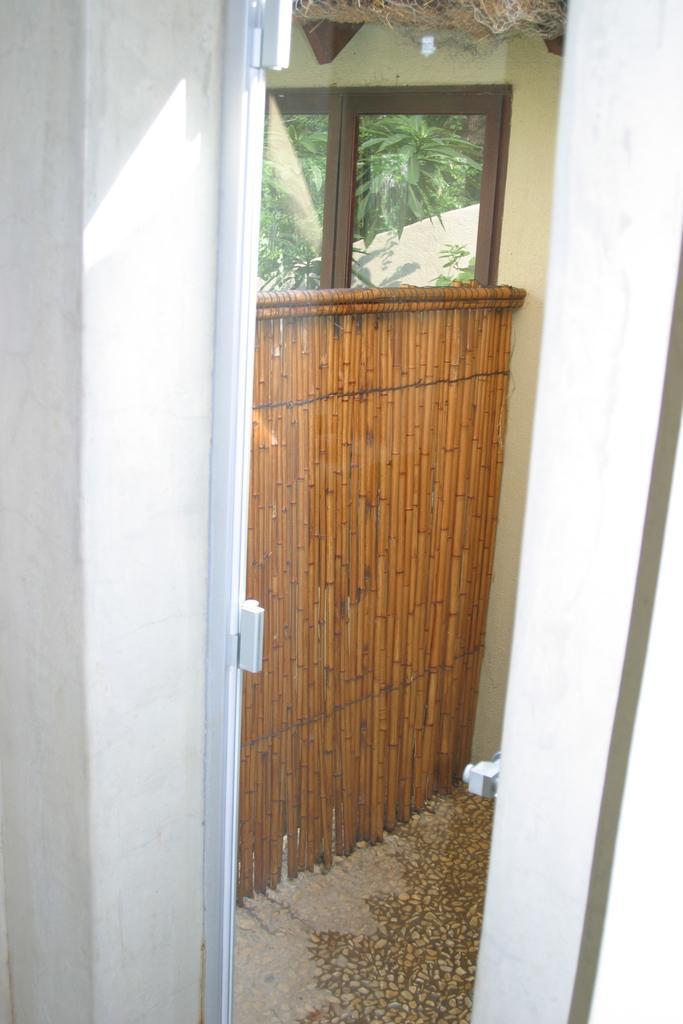Can you describe this image briefly? In this picture we can see few glasses and a wooden door, in the background we can see few trees. 